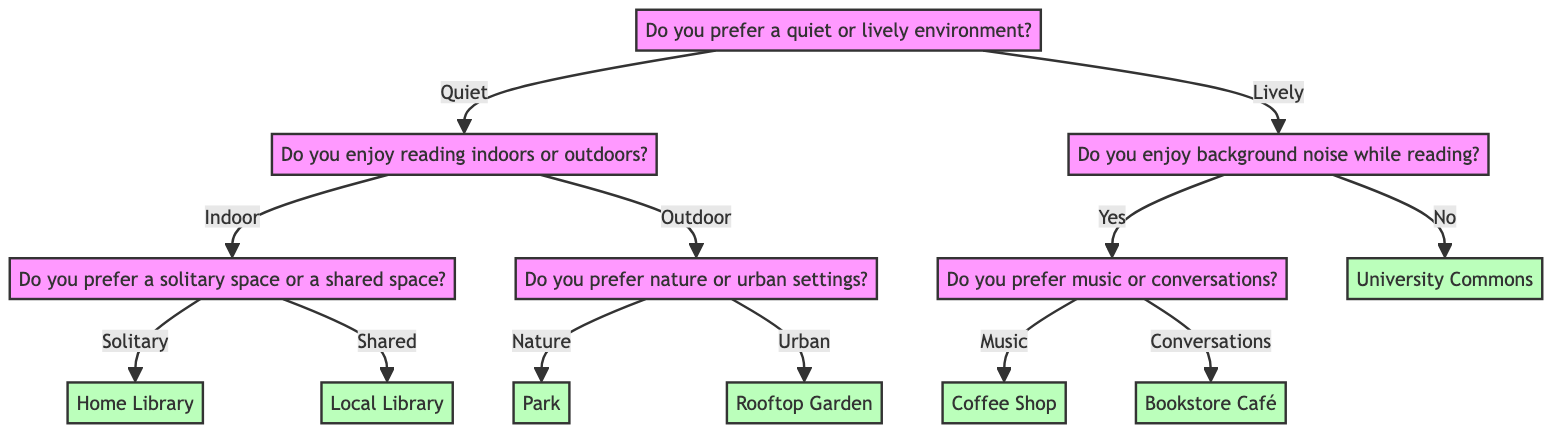What is the first question in the diagram? The first question in the diagram is located at the root node, which is "Do you prefer a quiet or lively environment?"
Answer: Do you prefer a quiet or lively environment? How many recommended reading environments are there in total? To find the total number of recommended reading environments, we can count all the leaf nodes in the diagram. There are six distinct environments: Home Library, Local Library, Park, Rooftop Garden, Coffee Shop, Bookstore Café, and University Commons, which totals to six.
Answer: 6 What reading environment is recommended for someone who prefers quiet and enjoys reading outdoors in nature? Following the path for someone who prefers a quiet environment leads to the question about reading indoors or outdoors. Choosing outdoors and then nature leads to the recommendation of "Park."
Answer: Park If someone prefers lively environments but does not enjoy background noise, what is their recommended reading environment? The path for someone who prefers a lively environment and does not enjoy background noise leads directly to the recommendation "University Commons."
Answer: University Commons In the diagram, which recommended reading environment is associated with shared indoor spaces? Tracing the path for someone who prefers quiet and reads indoors, the subsequent question about solitary or shared spaces leads to selecting a shared space, which then results in the recommendation of "Local Library."
Answer: Local Library Which option follows after selecting a lively environment and enjoying background noise? Following the path for a lively environment and indicating enjoyment of background noise leads to the next question about preferring music or conversations. Therefore, the next step in the decision tree is related to this question.
Answer: Do you prefer music or conversations? What unique detail is suggested for setting up a home library? The recommendation for "Home Library" includes a detail that describes setting up a cozy reading nook with comfortable seating and good lighting.
Answer: Cozy reading nook with comfortable seating and good lighting What is the outcome if someone prefers a lively environment but does not enjoy background noise? For someone who prefers a lively environment and does not enjoy background noise, the flow leads directly to the recommendation "University Commons."
Answer: University Commons Which two reading environments require a preference for music and conversations? Within the lively branch for those who enjoy background noise, the specific pathways lead to two distinct options: selecting music leads to "Coffee Shop," and choosing conversations leads to "Bookstore Café."
Answer: Coffee Shop and Bookstore Café 